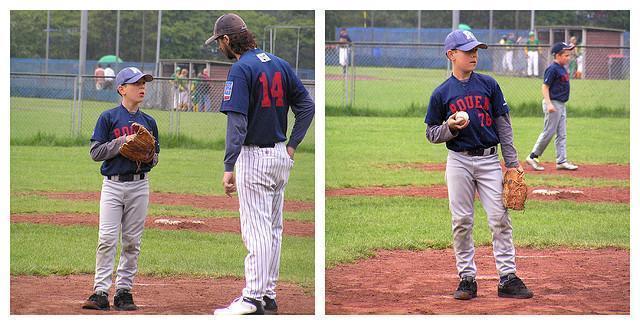What color is the text for this jersey of the boy playing baseball?
Make your selection from the four choices given to correctly answer the question.
Options: White, red, blue, yellow. Red. 